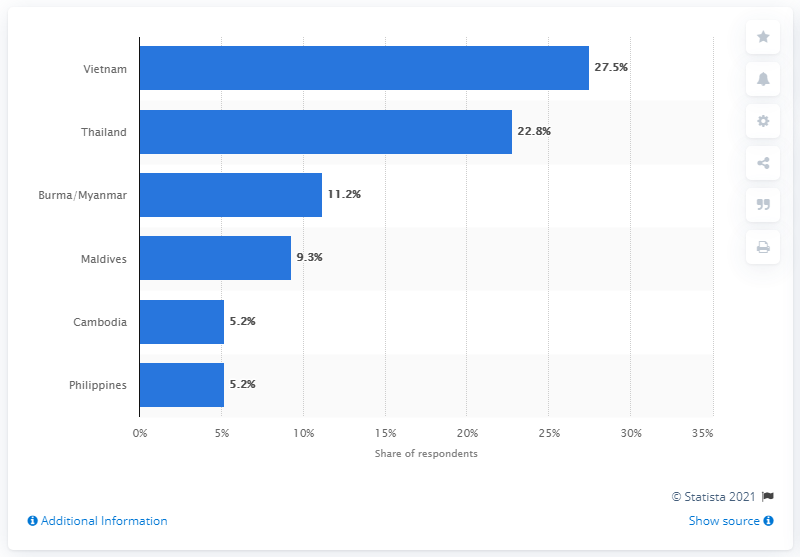Mention a couple of crucial points in this snapshot. The most promising travel destination in Asia and Southeast Asia for 2015 was Vietnam, which was regarded as up and coming. 